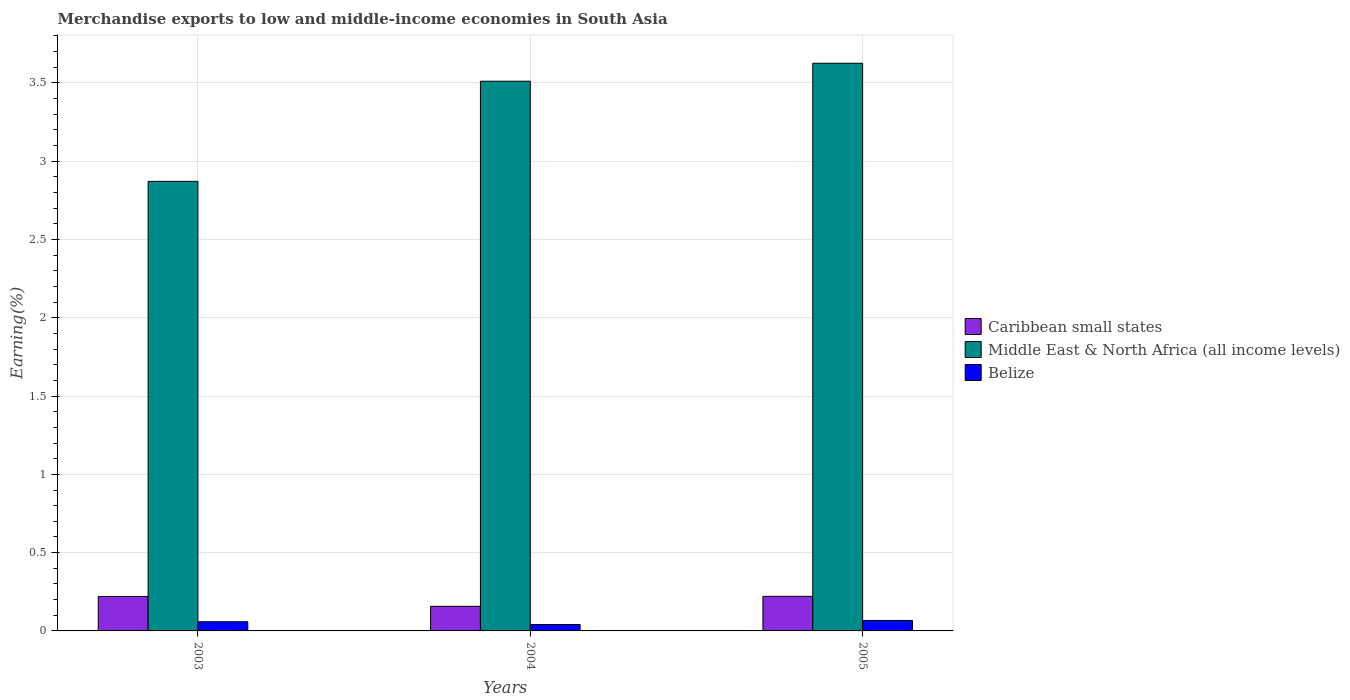How many different coloured bars are there?
Your response must be concise. 3. How many groups of bars are there?
Your response must be concise. 3. Are the number of bars per tick equal to the number of legend labels?
Your answer should be very brief. Yes. How many bars are there on the 2nd tick from the left?
Keep it short and to the point. 3. How many bars are there on the 3rd tick from the right?
Ensure brevity in your answer.  3. What is the label of the 2nd group of bars from the left?
Offer a terse response. 2004. In how many cases, is the number of bars for a given year not equal to the number of legend labels?
Provide a short and direct response. 0. What is the percentage of amount earned from merchandise exports in Caribbean small states in 2004?
Your answer should be compact. 0.16. Across all years, what is the maximum percentage of amount earned from merchandise exports in Middle East & North Africa (all income levels)?
Keep it short and to the point. 3.63. Across all years, what is the minimum percentage of amount earned from merchandise exports in Middle East & North Africa (all income levels)?
Provide a short and direct response. 2.87. In which year was the percentage of amount earned from merchandise exports in Middle East & North Africa (all income levels) maximum?
Your answer should be compact. 2005. What is the total percentage of amount earned from merchandise exports in Middle East & North Africa (all income levels) in the graph?
Offer a very short reply. 10.01. What is the difference between the percentage of amount earned from merchandise exports in Caribbean small states in 2003 and that in 2005?
Provide a short and direct response. -0. What is the difference between the percentage of amount earned from merchandise exports in Belize in 2005 and the percentage of amount earned from merchandise exports in Middle East & North Africa (all income levels) in 2004?
Keep it short and to the point. -3.44. What is the average percentage of amount earned from merchandise exports in Caribbean small states per year?
Ensure brevity in your answer.  0.2. In the year 2003, what is the difference between the percentage of amount earned from merchandise exports in Caribbean small states and percentage of amount earned from merchandise exports in Belize?
Ensure brevity in your answer.  0.16. In how many years, is the percentage of amount earned from merchandise exports in Caribbean small states greater than 0.9 %?
Provide a succinct answer. 0. What is the ratio of the percentage of amount earned from merchandise exports in Belize in 2003 to that in 2005?
Keep it short and to the point. 0.88. What is the difference between the highest and the second highest percentage of amount earned from merchandise exports in Belize?
Offer a terse response. 0.01. What is the difference between the highest and the lowest percentage of amount earned from merchandise exports in Middle East & North Africa (all income levels)?
Offer a very short reply. 0.75. Is the sum of the percentage of amount earned from merchandise exports in Caribbean small states in 2003 and 2005 greater than the maximum percentage of amount earned from merchandise exports in Belize across all years?
Your response must be concise. Yes. What does the 1st bar from the left in 2003 represents?
Your answer should be very brief. Caribbean small states. What does the 1st bar from the right in 2005 represents?
Provide a succinct answer. Belize. Are all the bars in the graph horizontal?
Offer a very short reply. No. How many years are there in the graph?
Offer a terse response. 3. Are the values on the major ticks of Y-axis written in scientific E-notation?
Offer a terse response. No. Does the graph contain any zero values?
Your answer should be compact. No. Does the graph contain grids?
Provide a short and direct response. Yes. Where does the legend appear in the graph?
Ensure brevity in your answer.  Center right. How are the legend labels stacked?
Make the answer very short. Vertical. What is the title of the graph?
Keep it short and to the point. Merchandise exports to low and middle-income economies in South Asia. What is the label or title of the Y-axis?
Your answer should be compact. Earning(%). What is the Earning(%) in Caribbean small states in 2003?
Provide a succinct answer. 0.22. What is the Earning(%) of Middle East & North Africa (all income levels) in 2003?
Ensure brevity in your answer.  2.87. What is the Earning(%) of Belize in 2003?
Provide a succinct answer. 0.06. What is the Earning(%) in Caribbean small states in 2004?
Your response must be concise. 0.16. What is the Earning(%) in Middle East & North Africa (all income levels) in 2004?
Offer a terse response. 3.51. What is the Earning(%) in Belize in 2004?
Your response must be concise. 0.04. What is the Earning(%) of Caribbean small states in 2005?
Provide a short and direct response. 0.22. What is the Earning(%) in Middle East & North Africa (all income levels) in 2005?
Provide a succinct answer. 3.63. What is the Earning(%) of Belize in 2005?
Offer a very short reply. 0.07. Across all years, what is the maximum Earning(%) of Caribbean small states?
Give a very brief answer. 0.22. Across all years, what is the maximum Earning(%) in Middle East & North Africa (all income levels)?
Give a very brief answer. 3.63. Across all years, what is the maximum Earning(%) in Belize?
Your response must be concise. 0.07. Across all years, what is the minimum Earning(%) of Caribbean small states?
Your answer should be very brief. 0.16. Across all years, what is the minimum Earning(%) of Middle East & North Africa (all income levels)?
Offer a terse response. 2.87. Across all years, what is the minimum Earning(%) in Belize?
Your answer should be very brief. 0.04. What is the total Earning(%) of Caribbean small states in the graph?
Your response must be concise. 0.6. What is the total Earning(%) in Middle East & North Africa (all income levels) in the graph?
Your response must be concise. 10.01. What is the total Earning(%) of Belize in the graph?
Provide a short and direct response. 0.17. What is the difference between the Earning(%) in Caribbean small states in 2003 and that in 2004?
Your answer should be very brief. 0.06. What is the difference between the Earning(%) of Middle East & North Africa (all income levels) in 2003 and that in 2004?
Offer a terse response. -0.64. What is the difference between the Earning(%) of Belize in 2003 and that in 2004?
Make the answer very short. 0.02. What is the difference between the Earning(%) of Caribbean small states in 2003 and that in 2005?
Give a very brief answer. -0. What is the difference between the Earning(%) in Middle East & North Africa (all income levels) in 2003 and that in 2005?
Provide a short and direct response. -0.75. What is the difference between the Earning(%) of Belize in 2003 and that in 2005?
Offer a very short reply. -0.01. What is the difference between the Earning(%) of Caribbean small states in 2004 and that in 2005?
Offer a terse response. -0.06. What is the difference between the Earning(%) in Middle East & North Africa (all income levels) in 2004 and that in 2005?
Ensure brevity in your answer.  -0.11. What is the difference between the Earning(%) of Belize in 2004 and that in 2005?
Make the answer very short. -0.03. What is the difference between the Earning(%) in Caribbean small states in 2003 and the Earning(%) in Middle East & North Africa (all income levels) in 2004?
Your answer should be very brief. -3.29. What is the difference between the Earning(%) in Caribbean small states in 2003 and the Earning(%) in Belize in 2004?
Keep it short and to the point. 0.18. What is the difference between the Earning(%) in Middle East & North Africa (all income levels) in 2003 and the Earning(%) in Belize in 2004?
Your response must be concise. 2.83. What is the difference between the Earning(%) in Caribbean small states in 2003 and the Earning(%) in Middle East & North Africa (all income levels) in 2005?
Make the answer very short. -3.41. What is the difference between the Earning(%) in Caribbean small states in 2003 and the Earning(%) in Belize in 2005?
Your response must be concise. 0.15. What is the difference between the Earning(%) in Middle East & North Africa (all income levels) in 2003 and the Earning(%) in Belize in 2005?
Give a very brief answer. 2.8. What is the difference between the Earning(%) in Caribbean small states in 2004 and the Earning(%) in Middle East & North Africa (all income levels) in 2005?
Provide a succinct answer. -3.47. What is the difference between the Earning(%) in Caribbean small states in 2004 and the Earning(%) in Belize in 2005?
Your response must be concise. 0.09. What is the difference between the Earning(%) of Middle East & North Africa (all income levels) in 2004 and the Earning(%) of Belize in 2005?
Offer a terse response. 3.44. What is the average Earning(%) of Caribbean small states per year?
Keep it short and to the point. 0.2. What is the average Earning(%) of Middle East & North Africa (all income levels) per year?
Ensure brevity in your answer.  3.34. What is the average Earning(%) of Belize per year?
Provide a short and direct response. 0.06. In the year 2003, what is the difference between the Earning(%) in Caribbean small states and Earning(%) in Middle East & North Africa (all income levels)?
Keep it short and to the point. -2.65. In the year 2003, what is the difference between the Earning(%) of Caribbean small states and Earning(%) of Belize?
Offer a terse response. 0.16. In the year 2003, what is the difference between the Earning(%) in Middle East & North Africa (all income levels) and Earning(%) in Belize?
Ensure brevity in your answer.  2.81. In the year 2004, what is the difference between the Earning(%) of Caribbean small states and Earning(%) of Middle East & North Africa (all income levels)?
Provide a short and direct response. -3.35. In the year 2004, what is the difference between the Earning(%) of Caribbean small states and Earning(%) of Belize?
Ensure brevity in your answer.  0.12. In the year 2004, what is the difference between the Earning(%) of Middle East & North Africa (all income levels) and Earning(%) of Belize?
Offer a very short reply. 3.47. In the year 2005, what is the difference between the Earning(%) of Caribbean small states and Earning(%) of Middle East & North Africa (all income levels)?
Ensure brevity in your answer.  -3.4. In the year 2005, what is the difference between the Earning(%) of Caribbean small states and Earning(%) of Belize?
Give a very brief answer. 0.15. In the year 2005, what is the difference between the Earning(%) of Middle East & North Africa (all income levels) and Earning(%) of Belize?
Provide a short and direct response. 3.56. What is the ratio of the Earning(%) of Caribbean small states in 2003 to that in 2004?
Make the answer very short. 1.4. What is the ratio of the Earning(%) of Middle East & North Africa (all income levels) in 2003 to that in 2004?
Your answer should be compact. 0.82. What is the ratio of the Earning(%) of Belize in 2003 to that in 2004?
Your answer should be compact. 1.44. What is the ratio of the Earning(%) in Middle East & North Africa (all income levels) in 2003 to that in 2005?
Give a very brief answer. 0.79. What is the ratio of the Earning(%) in Belize in 2003 to that in 2005?
Keep it short and to the point. 0.88. What is the ratio of the Earning(%) in Caribbean small states in 2004 to that in 2005?
Your answer should be very brief. 0.71. What is the ratio of the Earning(%) of Middle East & North Africa (all income levels) in 2004 to that in 2005?
Ensure brevity in your answer.  0.97. What is the ratio of the Earning(%) of Belize in 2004 to that in 2005?
Offer a terse response. 0.61. What is the difference between the highest and the second highest Earning(%) of Caribbean small states?
Offer a very short reply. 0. What is the difference between the highest and the second highest Earning(%) of Middle East & North Africa (all income levels)?
Your answer should be very brief. 0.11. What is the difference between the highest and the second highest Earning(%) of Belize?
Offer a very short reply. 0.01. What is the difference between the highest and the lowest Earning(%) of Caribbean small states?
Your response must be concise. 0.06. What is the difference between the highest and the lowest Earning(%) in Middle East & North Africa (all income levels)?
Your response must be concise. 0.75. What is the difference between the highest and the lowest Earning(%) in Belize?
Provide a short and direct response. 0.03. 